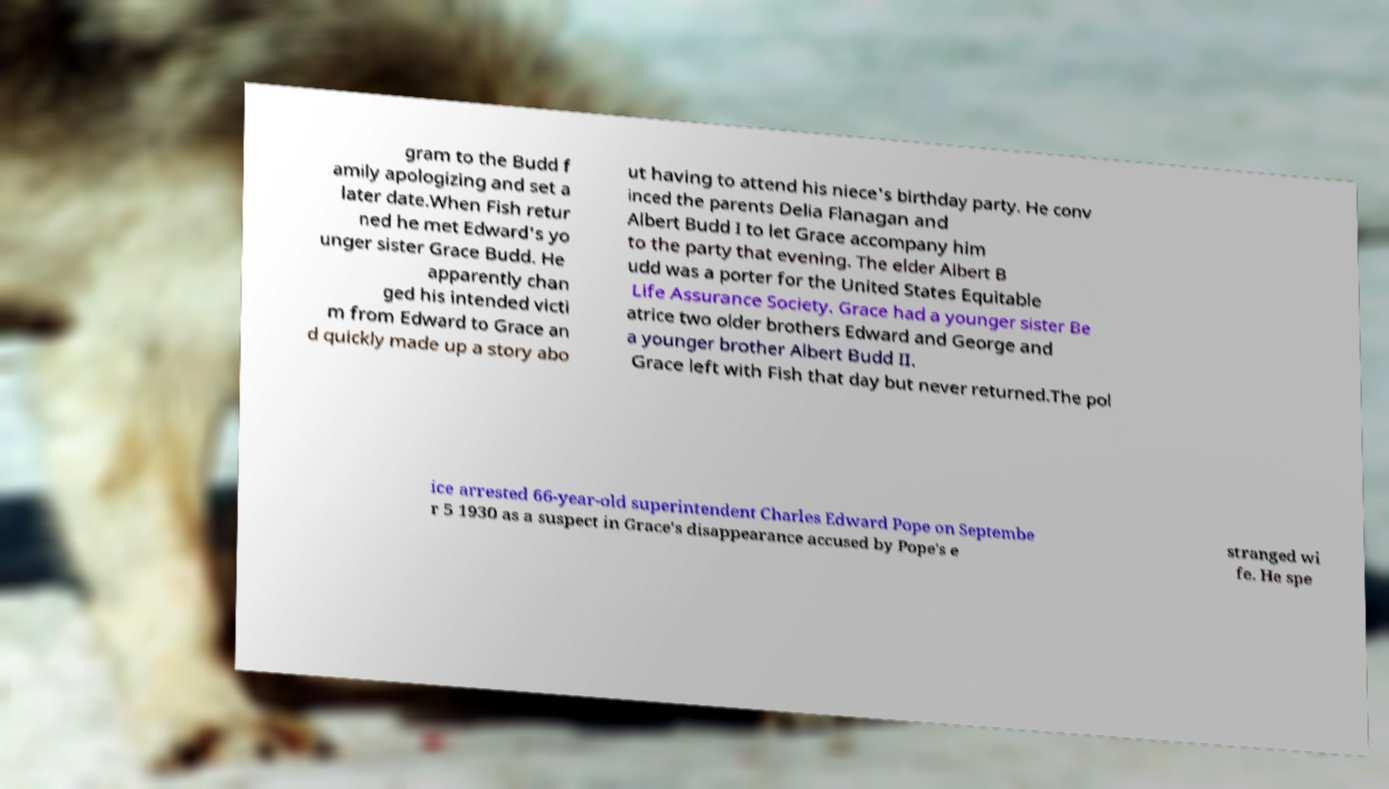Could you extract and type out the text from this image? gram to the Budd f amily apologizing and set a later date.When Fish retur ned he met Edward's yo unger sister Grace Budd. He apparently chan ged his intended victi m from Edward to Grace an d quickly made up a story abo ut having to attend his niece's birthday party. He conv inced the parents Delia Flanagan and Albert Budd I to let Grace accompany him to the party that evening. The elder Albert B udd was a porter for the United States Equitable Life Assurance Society. Grace had a younger sister Be atrice two older brothers Edward and George and a younger brother Albert Budd II. Grace left with Fish that day but never returned.The pol ice arrested 66-year-old superintendent Charles Edward Pope on Septembe r 5 1930 as a suspect in Grace's disappearance accused by Pope's e stranged wi fe. He spe 